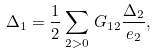Convert formula to latex. <formula><loc_0><loc_0><loc_500><loc_500>\Delta _ { 1 } = \frac { 1 } { 2 } \sum _ { 2 > 0 } \, G _ { 1 2 } \frac { \Delta _ { 2 } } { e _ { 2 } } ,</formula> 